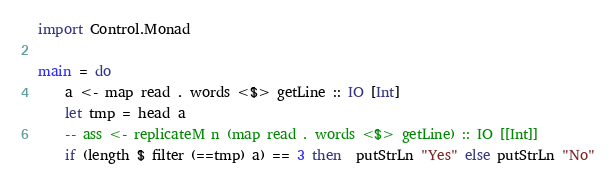Convert code to text. <code><loc_0><loc_0><loc_500><loc_500><_Haskell_>import Control.Monad

main = do 
    a <- map read . words <$> getLine :: IO [Int]
    let tmp = head a  
    -- ass <- replicateM n (map read . words <$> getLine) :: IO [[Int]]
    if (length $ filter (==tmp) a) == 3 then  putStrLn "Yes" else putStrLn "No"</code> 